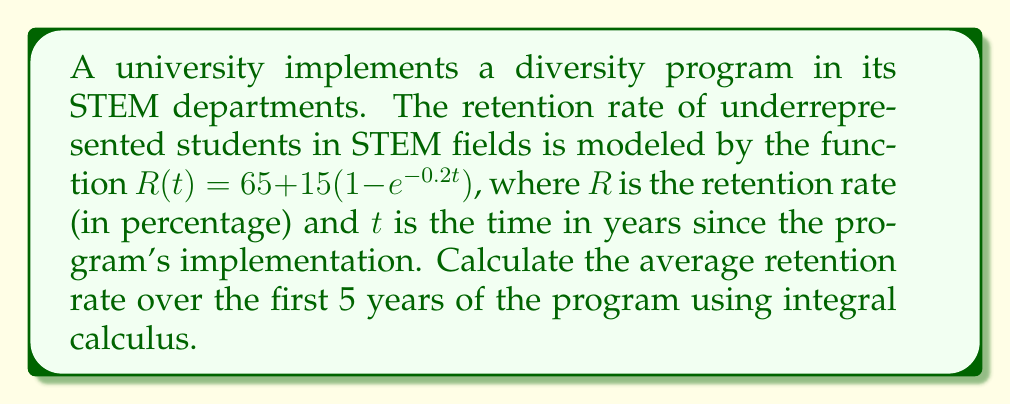Could you help me with this problem? To solve this problem, we need to use the concept of average value of a function over an interval. The formula for the average value of a function $f(x)$ over an interval $[a,b]$ is:

$$\text{Average Value} = \frac{1}{b-a} \int_a^b f(x) dx$$

In our case:
- $f(t) = R(t) = 65 + 15(1 - e^{-0.2t})$
- $a = 0$ (start of the program)
- $b = 5$ (end of 5-year period)

Let's calculate step by step:

1) Set up the integral:
   $$\text{Average Retention Rate} = \frac{1}{5-0} \int_0^5 [65 + 15(1 - e^{-0.2t})] dt$$

2) Simplify:
   $$= \frac{1}{5} \int_0^5 [65 + 15 - 15e^{-0.2t}] dt$$
   $$= \frac{1}{5} \int_0^5 [80 - 15e^{-0.2t}] dt$$

3) Integrate:
   $$= \frac{1}{5} [80t + \frac{15}{0.2}e^{-0.2t}]_0^5$$

4) Evaluate the integral:
   $$= \frac{1}{5} [(80 \cdot 5 + 75e^{-1}) - (0 + 75)]$$
   $$= \frac{1}{5} [400 + 75e^{-1} - 75]$$
   $$= \frac{1}{5} [325 + 75e^{-1}]$$
   $$= 65 + 15e^{-1}$$

5) Calculate the final value:
   $$= 65 + 15 \cdot 0.3679 \approx 70.52$$
Answer: The average retention rate over the first 5 years of the program is approximately 70.52%. 